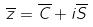Convert formula to latex. <formula><loc_0><loc_0><loc_500><loc_500>\overline { z } = \overline { C } + i \overline { S }</formula> 